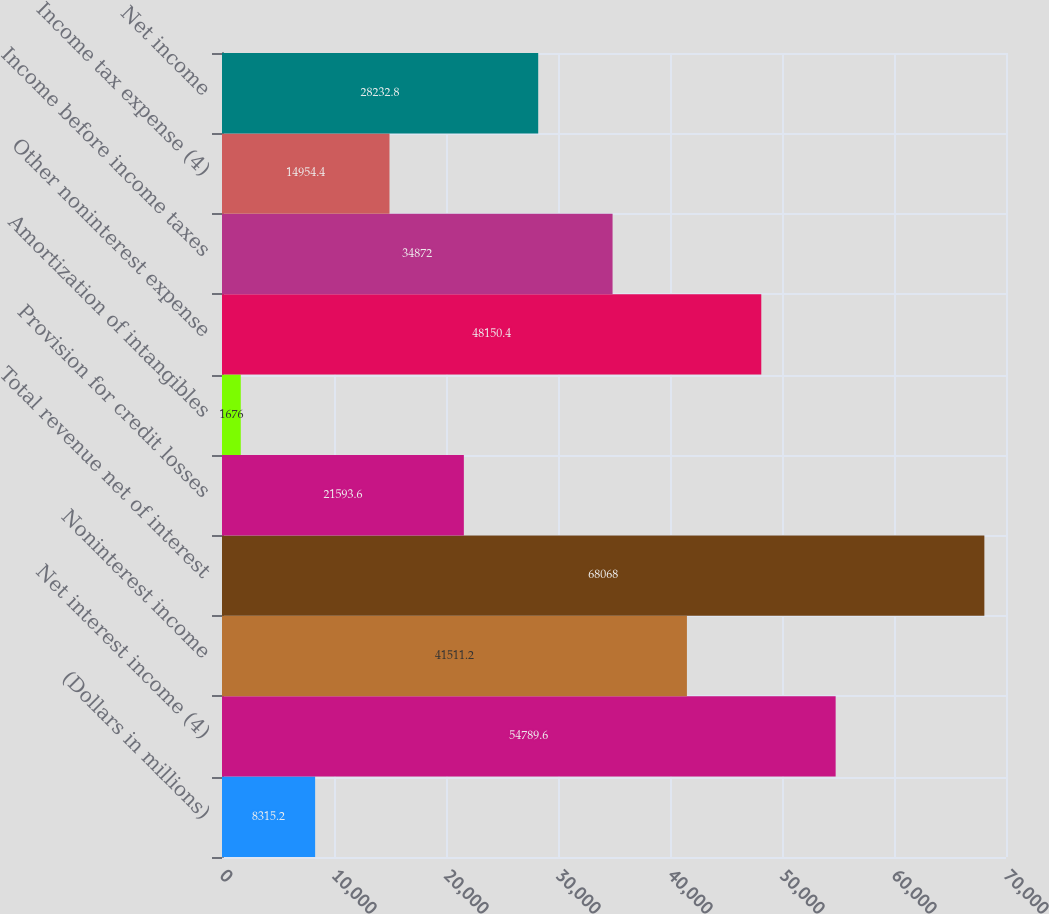Convert chart. <chart><loc_0><loc_0><loc_500><loc_500><bar_chart><fcel>(Dollars in millions)<fcel>Net interest income (4)<fcel>Noninterest income<fcel>Total revenue net of interest<fcel>Provision for credit losses<fcel>Amortization of intangibles<fcel>Other noninterest expense<fcel>Income before income taxes<fcel>Income tax expense (4)<fcel>Net income<nl><fcel>8315.2<fcel>54789.6<fcel>41511.2<fcel>68068<fcel>21593.6<fcel>1676<fcel>48150.4<fcel>34872<fcel>14954.4<fcel>28232.8<nl></chart> 